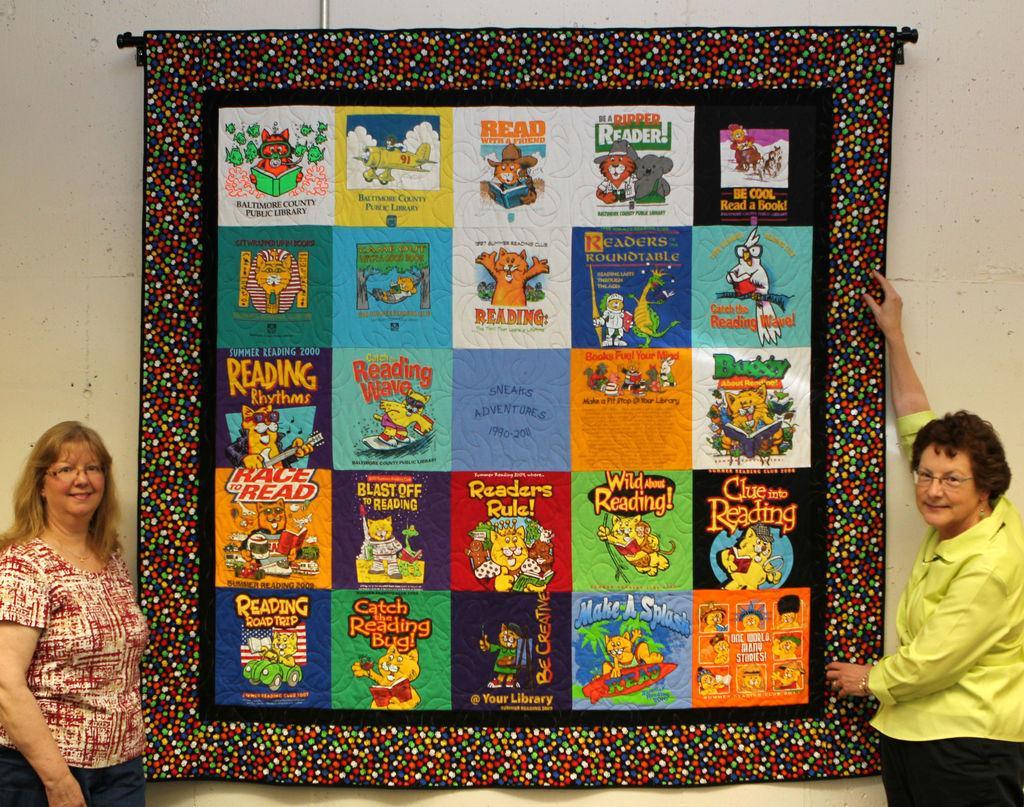In one or two sentences, can you explain what this image depicts? In this picture we can see two women, they wore spectacles, and we can see a patch work on the wall. 